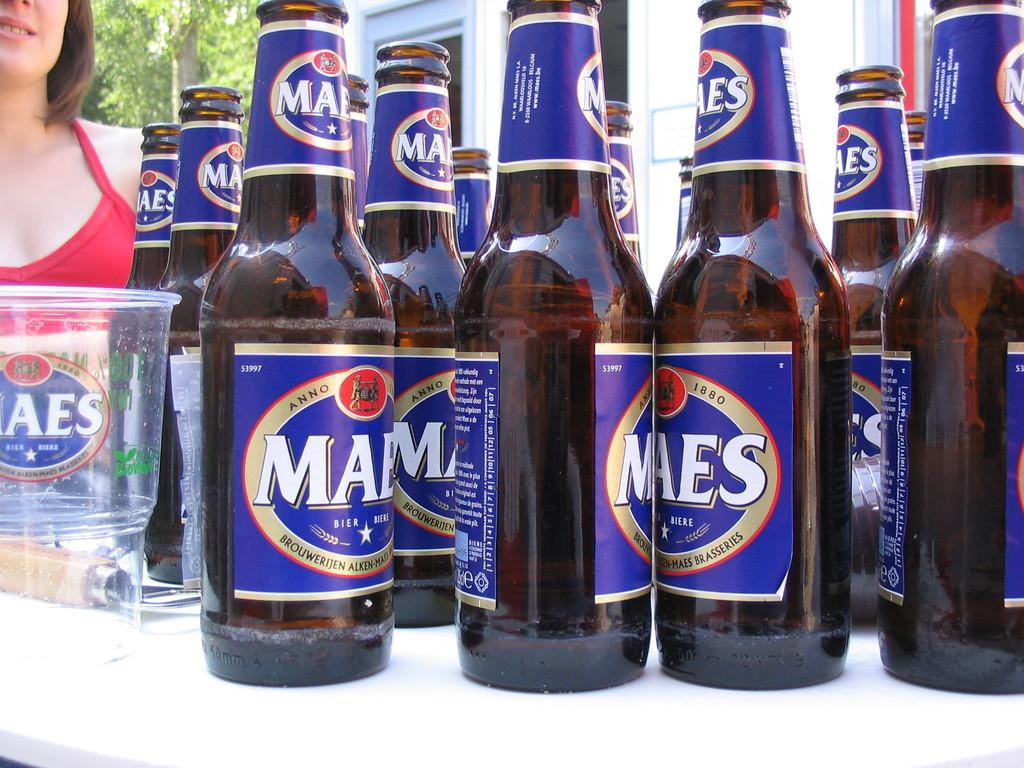<image>
Give a short and clear explanation of the subsequent image. Many bottles of Maes beer on top of a table. 